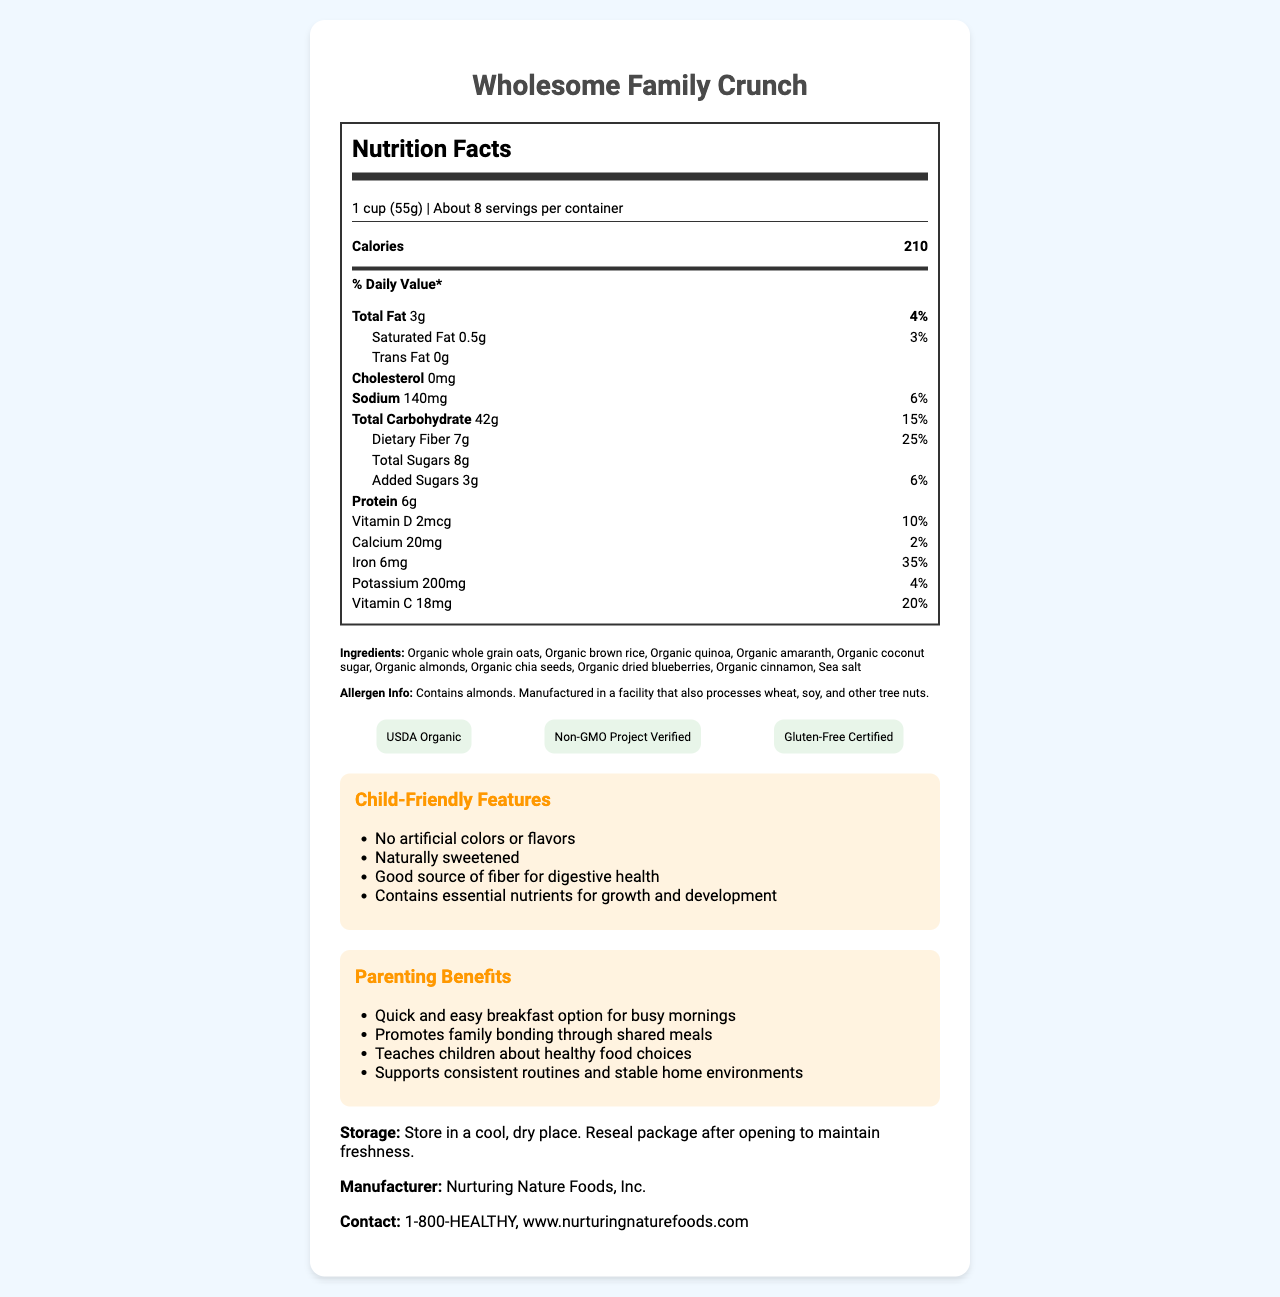Which product is the document describing? The title of the document specifies the product name as "Wholesome Family Crunch".
Answer: Wholesome Family Crunch What is the serving size of the cereal? The serving size is mentioned right after the product name under "Nutrition Facts".
Answer: 1 cup (55g) How many calories are in one serving? The calories per serving are listed under the "Nutrition Facts" section.
Answer: 210 What is the total fat content in one serving? It is listed under the "Total Fat" nutrient information in the nutrition label section.
Answer: 3g How much dietary fiber does one serving provide? The amount of dietary fiber is mentioned under the total carbohydrate section.
Answer: 7g List three organic grains included in the ingredients. These are listed in the ingredients section.
Answer: Organic whole grain oats, Organic brown rice, Organic quinoa Which company manufactures this product? The manufacturer is listed at the bottom of the document.
Answer: Nurturing Nature Foods, Inc. Is cholesterol present in this breakfast cereal? The cholesterol content is listed as "0mg".
Answer: No What percentage of the daily value of iron is provided in one serving? It is indicated in the nutrient information under iron.
Answer: 35% Select the correct total carbohydrate content in one serving: 
1) 32g 
2) 42g 
3) 50g The total carbohydrate content listed in the document is 42g.
Answer: 2 Which of the following features is not mentioned as a child-friendly feature?
A) Naturally sweetened
B) No artificial colors or flavors
C) Contains probiotics
D) Good source of fiber for digestive health The document does not mention "Contains probiotics" as a child-friendly feature.
Answer: C Does this cereal contain almonds? The allergen information specifically states, "Contains almonds".
Answer: Yes Summarize the main idea of the document. The document provides detailed information on the nutritional content and benefits of the breakfast cereal, including its child-friendly features and how it meets the needs of busy parents.
Answer: The document is a nutrition facts label for "Wholesome Family Crunch," an organic, whole-food-based breakfast cereal. It highlights nutritional benefits, ingredients, serving size, allergen info, child-friendly features, parenting benefits, storage instructions, and manufacturer details. Which vitamins are present in the cereal? The document lists Vitamin D (2mcg) and Vitamin C (18mg) in the nutrient information section.
Answer: Vitamin D and Vitamin C What is the contact information for the manufacturer? This is provided at the bottom under contact information.
Answer: 1-800-HEALTHY, www.nurturingnaturefoods.com What is the name of the company that also processes wheat, soy, and other tree nuts?
A) Wholesome Family Organics
B) Nutritious Grains LLC
C) Nurturing Nature Foods, Inc.
D) Health Harvest Inc. The allergen information states the product is "Manufactured in a facility that also processes wheat, soy, and other tree nuts," and the manufacturer is listed as "Nurturing Nature Foods, Inc."
Answer: C Which certification confirms that the product is free from genetically modified organisms? This certification is listed in the certifications section of the document.
Answer: Non-GMO Project Verified Can the document tell us the price of the cereal? The document provides nutritional and product details but does not mention the price.
Answer: Not enough information 